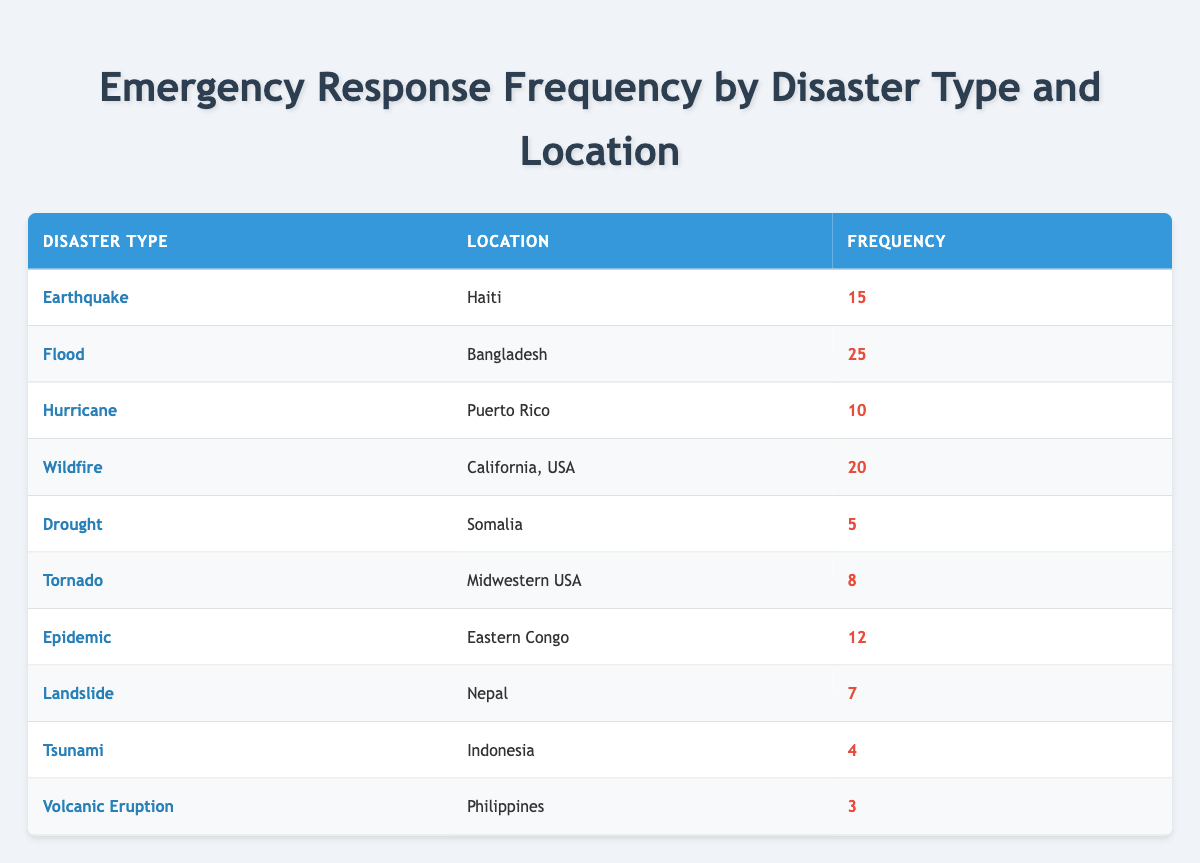What is the frequency of emergency responses for earthquakes in Haiti? The table lists earthquake responses in Haiti with a frequency of 15.
Answer: 15 Which disaster type has the highest frequency in this table? Reviewing the table, the flood in Bangladesh has the highest frequency at 25.
Answer: 25 How many total emergency responses have been recorded for all disasters combined? By summing the frequencies: 15 + 25 + 10 + 20 + 5 + 8 + 12 + 7 + 4 + 3 = 109.
Answer: 109 Is the frequency of emergency responses for volcanic eruptions greater than 5? The frequency for volcanic eruptions in the Philippines is 3, which is less than 5.
Answer: No What is the average frequency of emergency responses across all disaster types? There are 10 different disaster responses. The total frequency is 109. Therefore, the average is calculated as 109 / 10 = 10.9.
Answer: 10.9 How many responses were recorded for natural disasters (Earthquake, Flood, Hurricane, Wildfire, Drought, Tornado, Landslide, Tsunami, Volcanic Eruption) compared to epidemics? The total for natural disasters is 15 + 25 + 10 + 20 + 5 + 8 + 7 + 4 + 3 = 93. The frequency for epidemics is 12. Thus, 93 > 12.
Answer: Yes Which location has the second highest frequency of emergency responses, and what is the frequency? The second highest is California, USA, with a frequency of 20. The highest is Bangladesh with 25.
Answer: California, USA, 20 What is the difference in frequency of emergency responses between flood and drought? The frequency for flood is 25, and for drought is 5. The difference is 25 - 5 = 20.
Answer: 20 How many disaster types have a frequency less than 10? The frequency less than 10 includes Drought (5), Tornado (8), Landslide (7), Tsunami (4), and Volcanic Eruption (3). There are 5 disaster types in total.
Answer: 5 